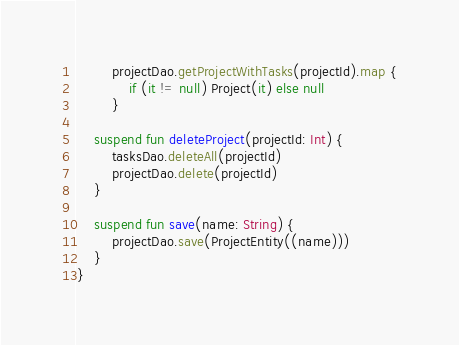<code> <loc_0><loc_0><loc_500><loc_500><_Kotlin_>        projectDao.getProjectWithTasks(projectId).map {
            if (it != null) Project(it) else null
        }

    suspend fun deleteProject(projectId: Int) {
        tasksDao.deleteAll(projectId)
        projectDao.delete(projectId)
    }

    suspend fun save(name: String) {
        projectDao.save(ProjectEntity((name)))
    }
}</code> 